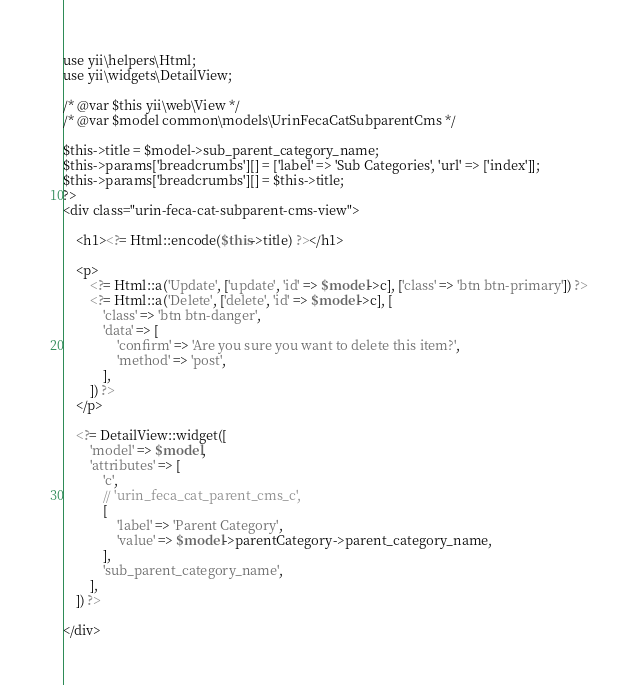Convert code to text. <code><loc_0><loc_0><loc_500><loc_500><_PHP_>
use yii\helpers\Html;
use yii\widgets\DetailView;

/* @var $this yii\web\View */
/* @var $model common\models\UrinFecaCatSubparentCms */

$this->title = $model->sub_parent_category_name;
$this->params['breadcrumbs'][] = ['label' => 'Sub Categories', 'url' => ['index']];
$this->params['breadcrumbs'][] = $this->title;
?>
<div class="urin-feca-cat-subparent-cms-view">

    <h1><?= Html::encode($this->title) ?></h1>

    <p>
        <?= Html::a('Update', ['update', 'id' => $model->c], ['class' => 'btn btn-primary']) ?>
        <?= Html::a('Delete', ['delete', 'id' => $model->c], [
            'class' => 'btn btn-danger',
            'data' => [
                'confirm' => 'Are you sure you want to delete this item?',
                'method' => 'post',
            ],
        ]) ?>
    </p>

    <?= DetailView::widget([
        'model' => $model,
        'attributes' => [
            'c',
            // 'urin_feca_cat_parent_cms_c',
            [
                'label' => 'Parent Category',
                'value' => $model->parentCategory->parent_category_name,
            ],
            'sub_parent_category_name',
        ],
    ]) ?>

</div>
</code> 